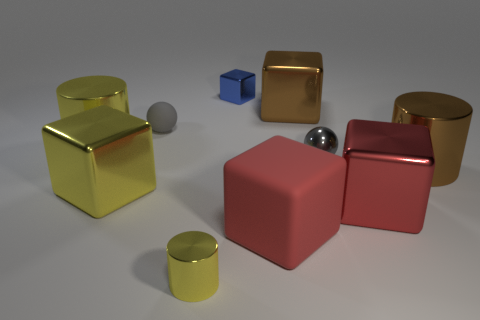Subtract all purple cubes. How many yellow cylinders are left? 2 Subtract all metal cubes. How many cubes are left? 1 Subtract all brown cylinders. How many cylinders are left? 2 Subtract 1 spheres. How many spheres are left? 1 Subtract all gray blocks. Subtract all blue balls. How many blocks are left? 5 Subtract all small blue metal blocks. Subtract all blue cubes. How many objects are left? 8 Add 8 small yellow cylinders. How many small yellow cylinders are left? 9 Add 8 tiny shiny cylinders. How many tiny shiny cylinders exist? 9 Subtract 0 red spheres. How many objects are left? 10 Subtract all spheres. How many objects are left? 8 